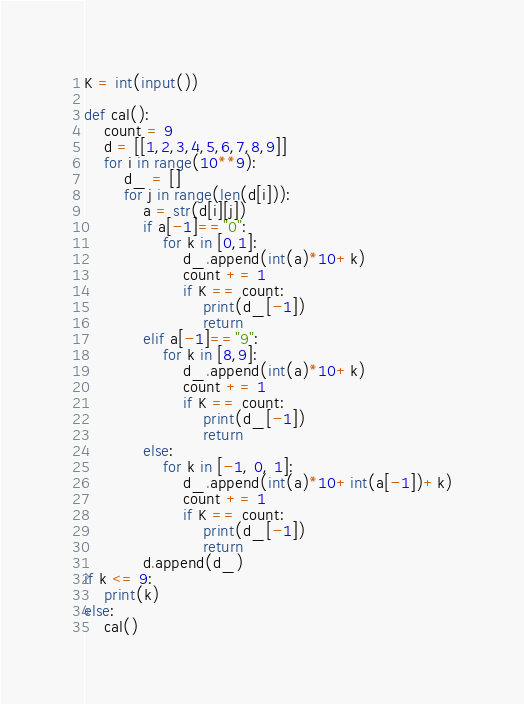<code> <loc_0><loc_0><loc_500><loc_500><_Python_>K = int(input())

def cal():
    count = 9
    d = [[1,2,3,4,5,6,7,8,9]]
    for i in range(10**9):
        d_ = []
        for j in range(len(d[i])):
            a = str(d[i][j])
            if a[-1]=="0":
                for k in [0,1]:
                    d_.append(int(a)*10+k)
                    count += 1
                    if K == count:
                        print(d_[-1])
                        return
            elif a[-1]=="9":
                for k in [8,9]:
                    d_.append(int(a)*10+k)
                    count += 1
                    if K == count:
                        print(d_[-1])
                        return 
            else:
                for k in [-1, 0, 1]:
                    d_.append(int(a)*10+int(a[-1])+k)
                    count += 1
                    if K == count:
                        print(d_[-1])
                        return
            d.append(d_)
if k <= 9:
    print(k)
else:
    cal()</code> 